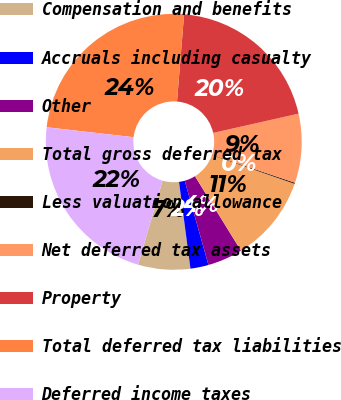Convert chart to OTSL. <chart><loc_0><loc_0><loc_500><loc_500><pie_chart><fcel>Compensation and benefits<fcel>Accruals including casualty<fcel>Other<fcel>Total gross deferred tax<fcel>Less valuation allowance<fcel>Net deferred tax assets<fcel>Property<fcel>Total deferred tax liabilities<fcel>Deferred income taxes<nl><fcel>6.58%<fcel>2.29%<fcel>4.43%<fcel>10.87%<fcel>0.14%<fcel>8.72%<fcel>20.18%<fcel>24.47%<fcel>22.32%<nl></chart> 